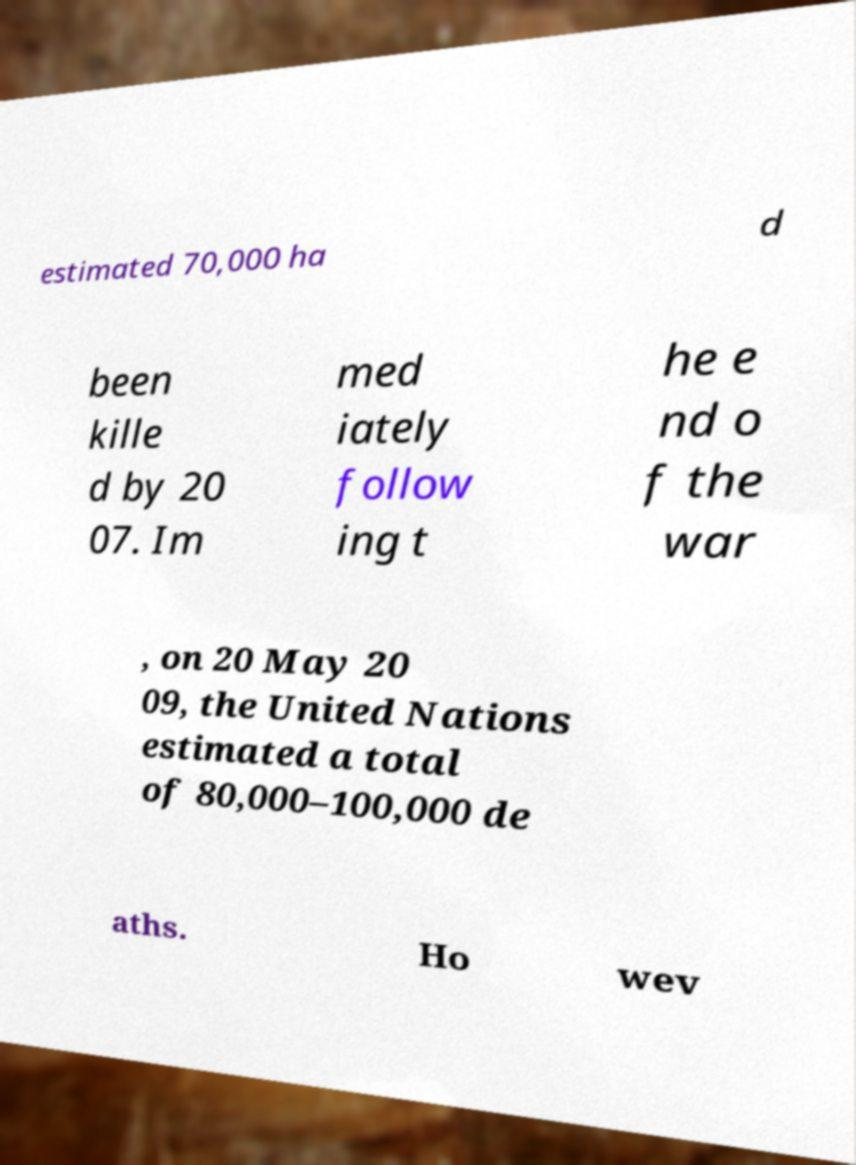Can you accurately transcribe the text from the provided image for me? estimated 70,000 ha d been kille d by 20 07. Im med iately follow ing t he e nd o f the war , on 20 May 20 09, the United Nations estimated a total of 80,000–100,000 de aths. Ho wev 